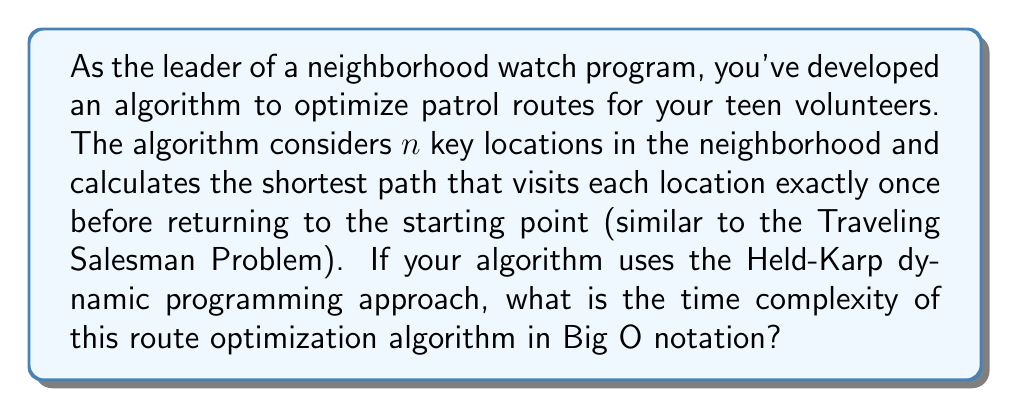Could you help me with this problem? To analyze the time complexity of this patrol route optimization algorithm, we need to understand the Held-Karp algorithm for solving the Traveling Salesman Problem (TSP):

1. The Held-Karp algorithm uses dynamic programming to solve the TSP.

2. It considers all possible subsets of vertices and all possible end vertices for each subset.

3. For each subset $S$ of size $k$ and each vertex $v$ in $S$, it computes the minimum cost path that visits each vertex in $S$ exactly once, starts at vertex 1, and ends at vertex $v$.

4. The number of subsets of $n$ vertices is $2^n$.

5. For each subset, we consider at most $n$ end vertices.

6. For each combination of subset and end vertex, we perform a constant number of operations.

Therefore, the time complexity can be calculated as follows:

$$ T(n) = O(n \cdot 2^n) $$

This is because:
- We have $2^n$ subsets
- For each subset, we consider at most $n$ end vertices
- The constant factor operations are absorbed in the Big O notation

It's worth noting that while this is a significant improvement over the naive $O(n!)$ approach, it's still exponential and becomes impractical for large values of $n$.

For the space complexity, the Held-Karp algorithm uses a table of size $O(n \cdot 2^n)$ to store the intermediate results, which matches the time complexity.
Answer: $O(n \cdot 2^n)$ 